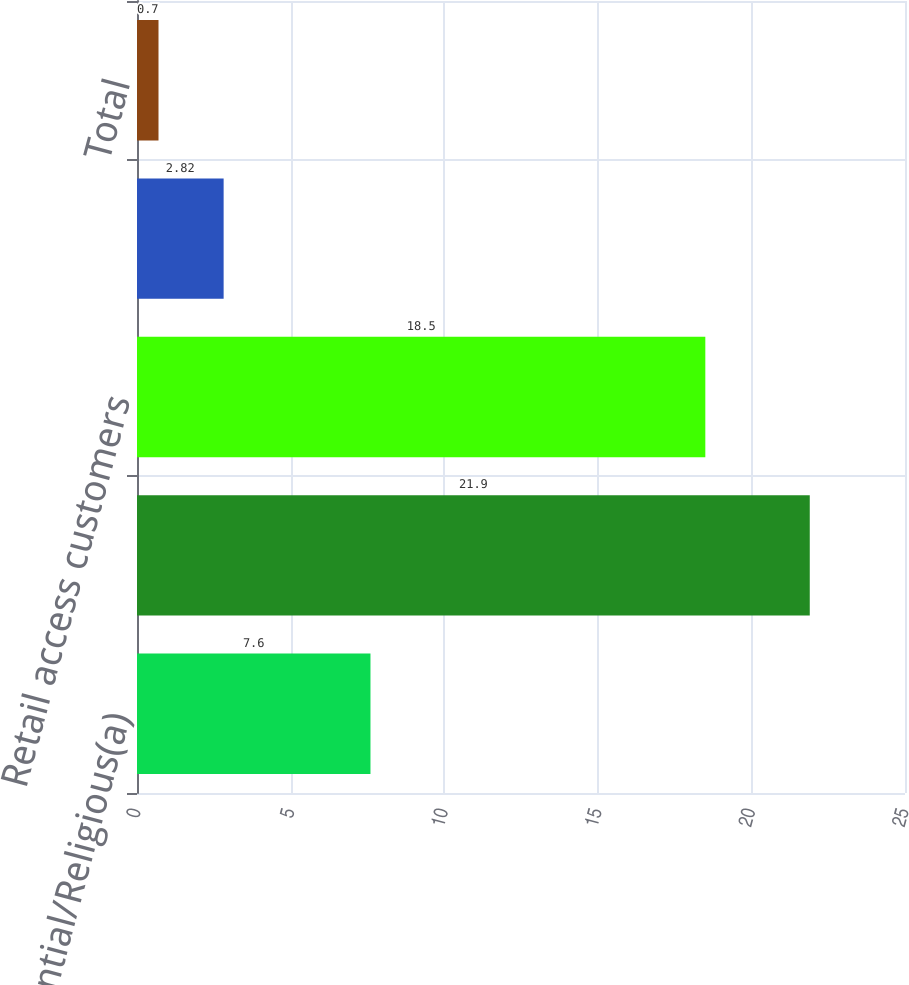Convert chart to OTSL. <chart><loc_0><loc_0><loc_500><loc_500><bar_chart><fcel>Residential/Religious(a)<fcel>Commercial/Industrial<fcel>Retail access customers<fcel>Public authorities<fcel>Total<nl><fcel>7.6<fcel>21.9<fcel>18.5<fcel>2.82<fcel>0.7<nl></chart> 